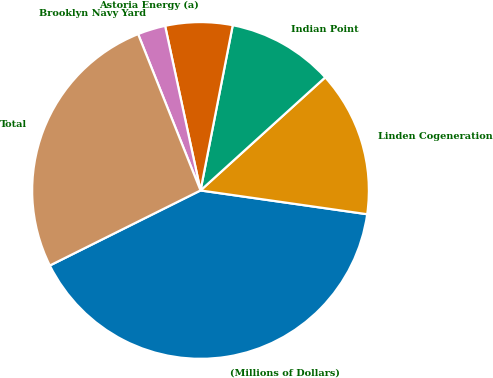<chart> <loc_0><loc_0><loc_500><loc_500><pie_chart><fcel>(Millions of Dollars)<fcel>Linden Cogeneration<fcel>Indian Point<fcel>Astoria Energy (a)<fcel>Brooklyn Navy Yard<fcel>Total<nl><fcel>40.39%<fcel>13.98%<fcel>10.21%<fcel>6.44%<fcel>2.67%<fcel>26.31%<nl></chart> 